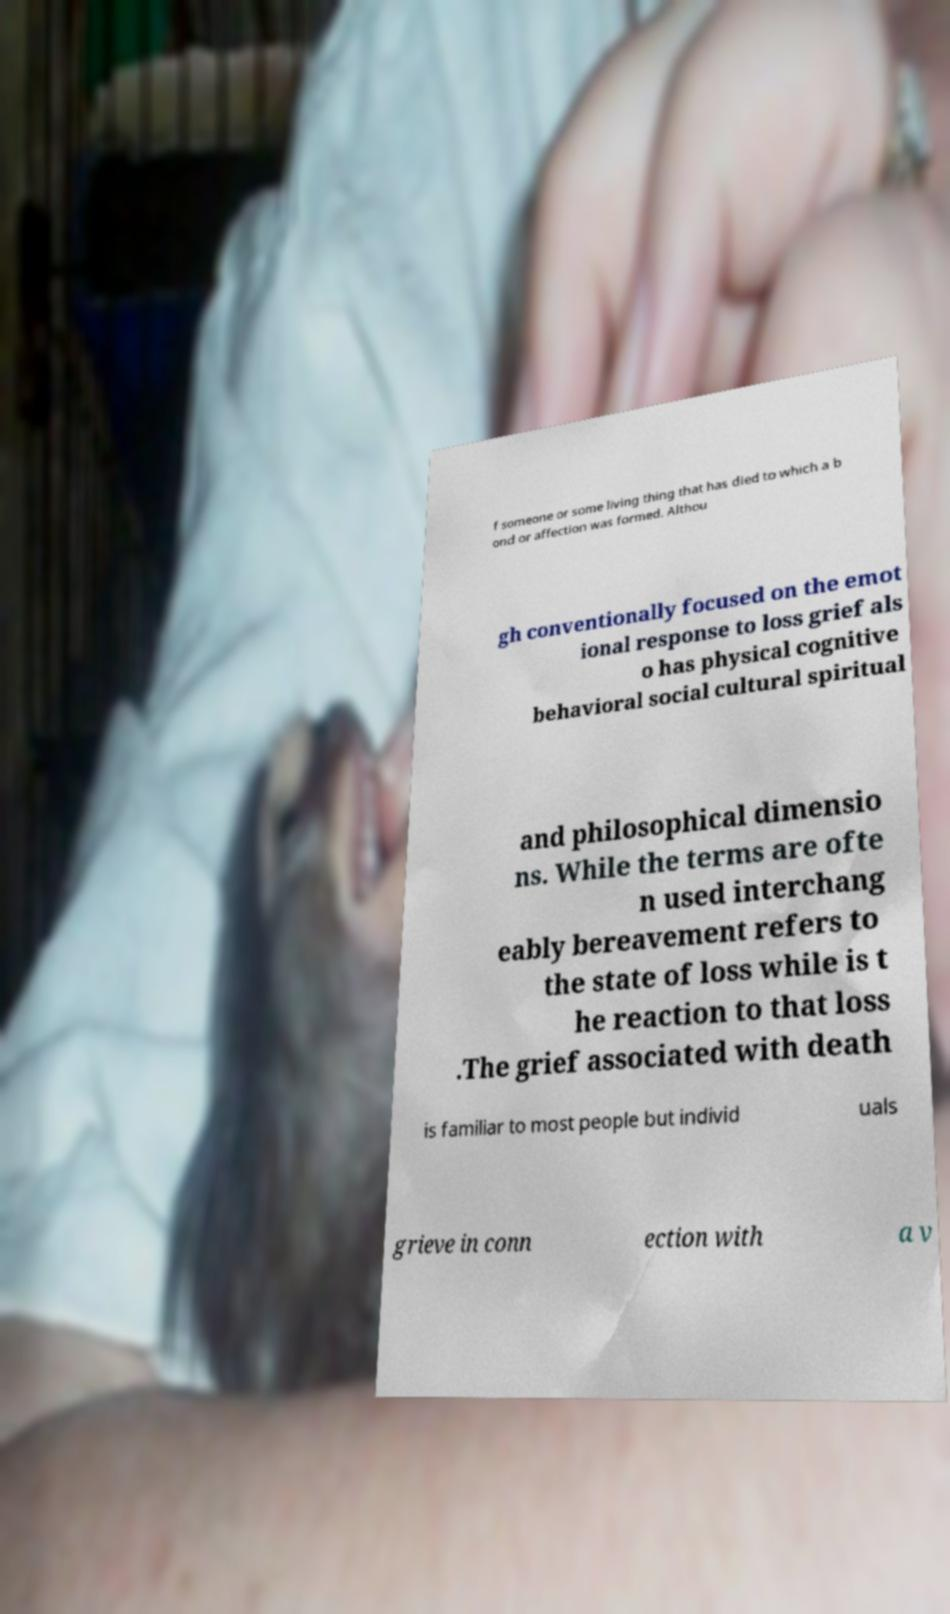Please identify and transcribe the text found in this image. f someone or some living thing that has died to which a b ond or affection was formed. Althou gh conventionally focused on the emot ional response to loss grief als o has physical cognitive behavioral social cultural spiritual and philosophical dimensio ns. While the terms are ofte n used interchang eably bereavement refers to the state of loss while is t he reaction to that loss .The grief associated with death is familiar to most people but individ uals grieve in conn ection with a v 